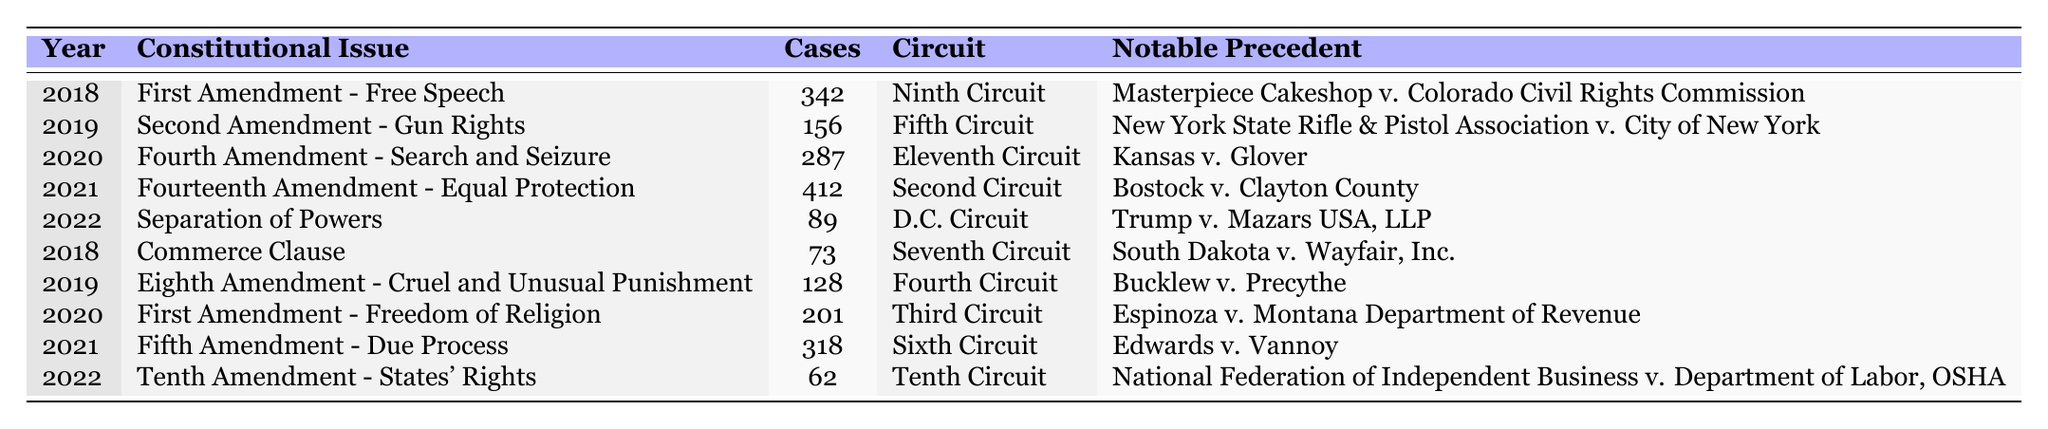What constitutional issue had the highest number of cases in 2021? In 2021, the Fourteenth Amendment - Equal Protection had 412 cases, which is more than any other constitutional issue listed for that year.
Answer: Fourteenth Amendment - Equal Protection Which circuit had the least number of cases related to constitutional issues in 2022? In 2022, the Tenth Circuit had 62 cases, which is the lowest compared to other circuits that year.
Answer: Tenth Circuit How many cases were related to the First Amendment across all years presented? There are two entries for the First Amendment: 342 cases in 2018 and 201 in 2020. The total is 342 + 201 = 543 cases.
Answer: 543 Did the number of cases for the Eighth Amendment in 2019 exceed the number of cases for the Tenth Amendment in 2022? The Eighth Amendment had 128 cases in 2019, while the Tenth Amendment had only 62 cases in 2022. Since 128 is greater than 62, the statement is true.
Answer: Yes What is the average number of cases for the constitutional issues from 2018 to 2022? The total number of cases from 2018 to 2022 is 342 + 73 + 156 + 412 + 89 + 128 + 201 + 287 + 318 + 62 = 1874. There are 10 entries, so the average is 1874/10 = 187.4.
Answer: 187.4 Which notable precedent corresponds with the most cases in the table, and what is the number of cases? The most cases are associated with the case "Bostock v. Clayton County" in 2021, which corresponds to 412 cases.
Answer: Bostock v. Clayton County, 412 cases Is there a significant difference in the number of cases between the years 2019 (Second Amendment) and 2022 (Separation of Powers)? In 2019, there were 156 cases, while in 2022, there were only 89 cases. The difference is 156 - 89 = 67 cases, indicating a significant drop.
Answer: Yes What percentage of the total cases in the table are represented by the Commerce Clause? The total number of cases is 1874, and the Commerce Clause has 73 cases. To find the percentage: (73/1874) * 100 = approximately 3.89%.
Answer: 3.89% Which constitutional issue had the highest number of cases in the Ninth Circuit based on the data? The First Amendment - Free Speech in 2018 had 342 cases listed under the Ninth Circuit.
Answer: First Amendment - Free Speech How many cases were related to the Fourth Amendment in total across all years? The table includes two entries for the Fourth Amendment: 287 cases in 2020 (Search and Seizure) and 128 cases in 2019 (Eighth Amendment). Therefore, the total number is 287 + 128 = 415.
Answer: 415 